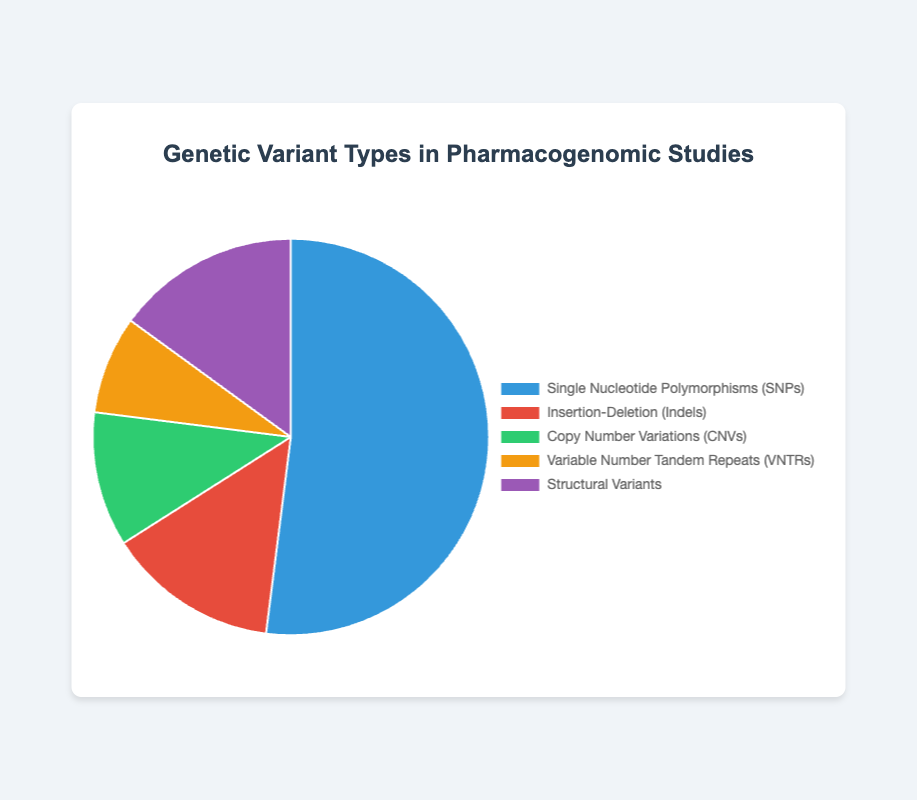What is the largest percentage represented by a genetic variant type in the pie chart? The largest percentage can be found by identifying the genetic variant with the highest value in the pie chart percentages. Single Nucleotide Polymorphisms (SNPs) has 52%, which is the highest.
Answer: 52% What genetic variant type has the smallest representation in the pie chart? The smallest percentage can be found by identifying the genetic variant with the lowest value in the pie chart percentages. Variable Number Tandem Repeats (VNTRs) has 8%, which is the lowest.
Answer: 8% What is the combined percentage of Indels and CNVs? To find the combined percentage, sum the percentages for Indels and CNVs. Indels have 14% and CNVs have 11%. So, 14 + 11 = 25.
Answer: 25% Which genetic variant type has a percentage closest to 15% in the pie chart? Comparing the percentages, the genetic variant type closest to 15% is Structural Variants, which exactly has 15%.
Answer: Structural Variants What is the difference between the percentages of SNPs and Structural Variants? Subtract the percentage of Structural Variants from the percentage of SNPs: 52 - 15 = 37.
Answer: 37% Are there any genetic variants types with percentages within 5% of each other? Comparing the percentages: Indels (14%) and Structural Variants (15%) are within 5% of each other.
Answer: Yes (Indels and Structural Variants) What is the total percentage represented by genetic variants other than SNPs? Sum the percentages of all genetic variants except SNPs: Indels (14) + CNVs (11) + VNTRs (8) + Structural Variants (15) = 48.
Answer: 48% If the values represented by the colors in the pie chart needed to be grouped into those above and below 20%, how many genetic variant types would be in each group? Grouping below 20%: Indels, CNVs, VNTRs, Structural Variants (4 types). Grouping above 20%: SNPs (1 type).
Answer: 4 below, 1 above 